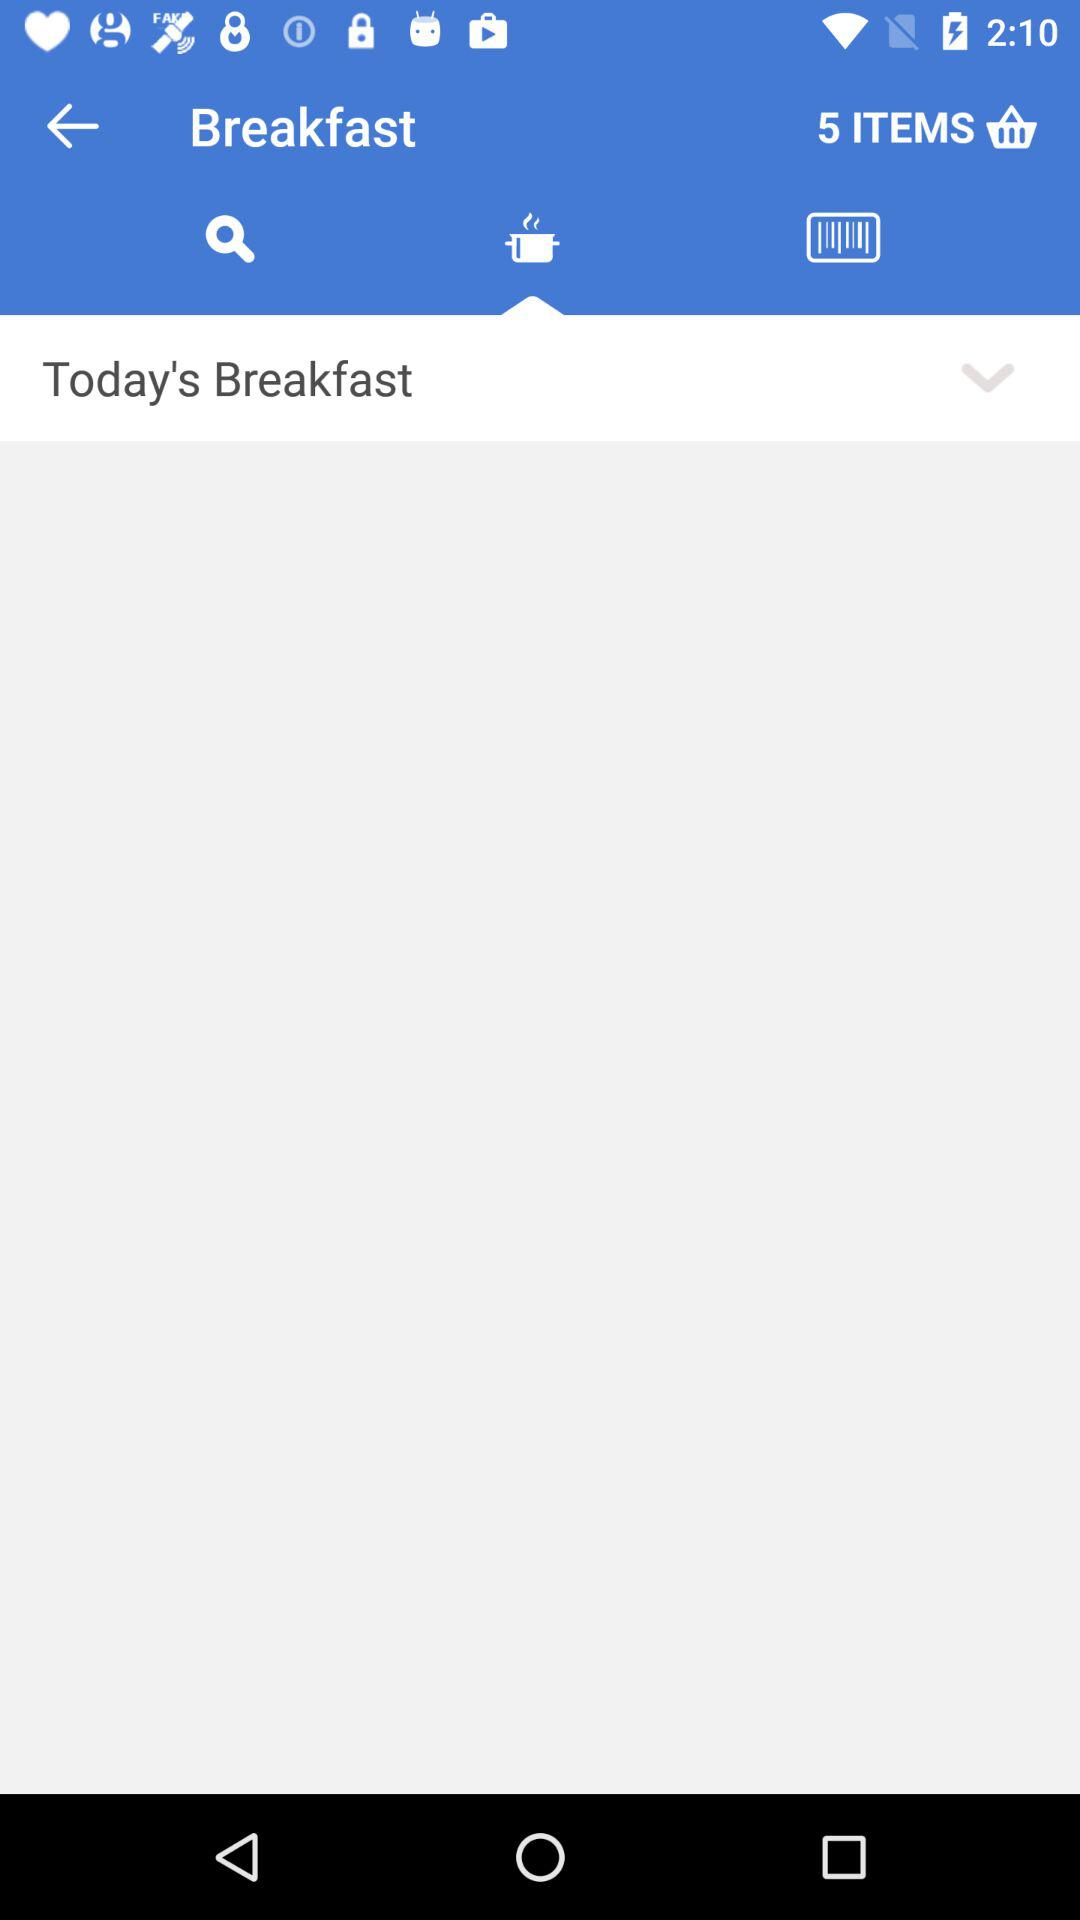How many items are in the shopping bag?
Answer the question using a single word or phrase. 5 